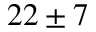Convert formula to latex. <formula><loc_0><loc_0><loc_500><loc_500>2 2 \pm 7</formula> 